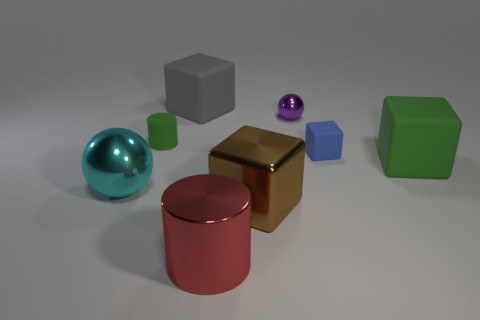Add 2 tiny spheres. How many objects exist? 10 Subtract all spheres. How many objects are left? 6 Subtract all large red objects. Subtract all tiny spheres. How many objects are left? 6 Add 4 tiny objects. How many tiny objects are left? 7 Add 6 small gray matte cylinders. How many small gray matte cylinders exist? 6 Subtract 0 green balls. How many objects are left? 8 